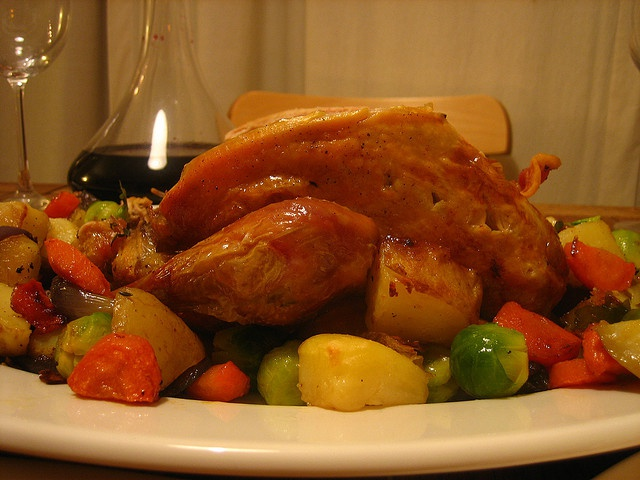Describe the objects in this image and their specific colors. I can see bottle in maroon, olive, and black tones, chair in maroon and orange tones, wine glass in maroon, olive, and gray tones, carrot in maroon, brown, and black tones, and carrot in maroon, brown, and red tones in this image. 